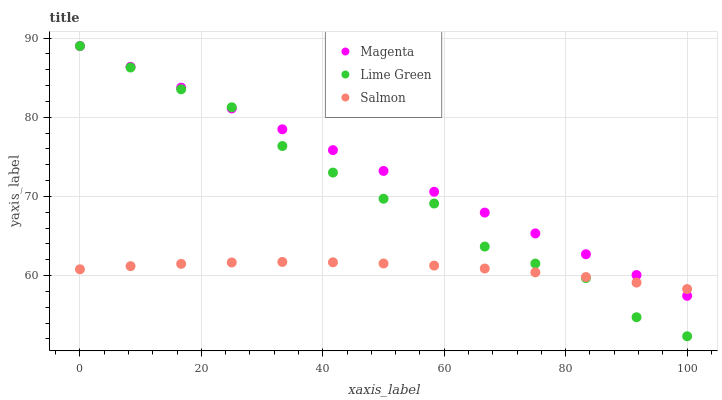Does Salmon have the minimum area under the curve?
Answer yes or no. Yes. Does Magenta have the maximum area under the curve?
Answer yes or no. Yes. Does Lime Green have the minimum area under the curve?
Answer yes or no. No. Does Lime Green have the maximum area under the curve?
Answer yes or no. No. Is Magenta the smoothest?
Answer yes or no. Yes. Is Lime Green the roughest?
Answer yes or no. Yes. Is Lime Green the smoothest?
Answer yes or no. No. Is Magenta the roughest?
Answer yes or no. No. Does Lime Green have the lowest value?
Answer yes or no. Yes. Does Magenta have the lowest value?
Answer yes or no. No. Does Lime Green have the highest value?
Answer yes or no. Yes. Does Lime Green intersect Salmon?
Answer yes or no. Yes. Is Lime Green less than Salmon?
Answer yes or no. No. Is Lime Green greater than Salmon?
Answer yes or no. No. 